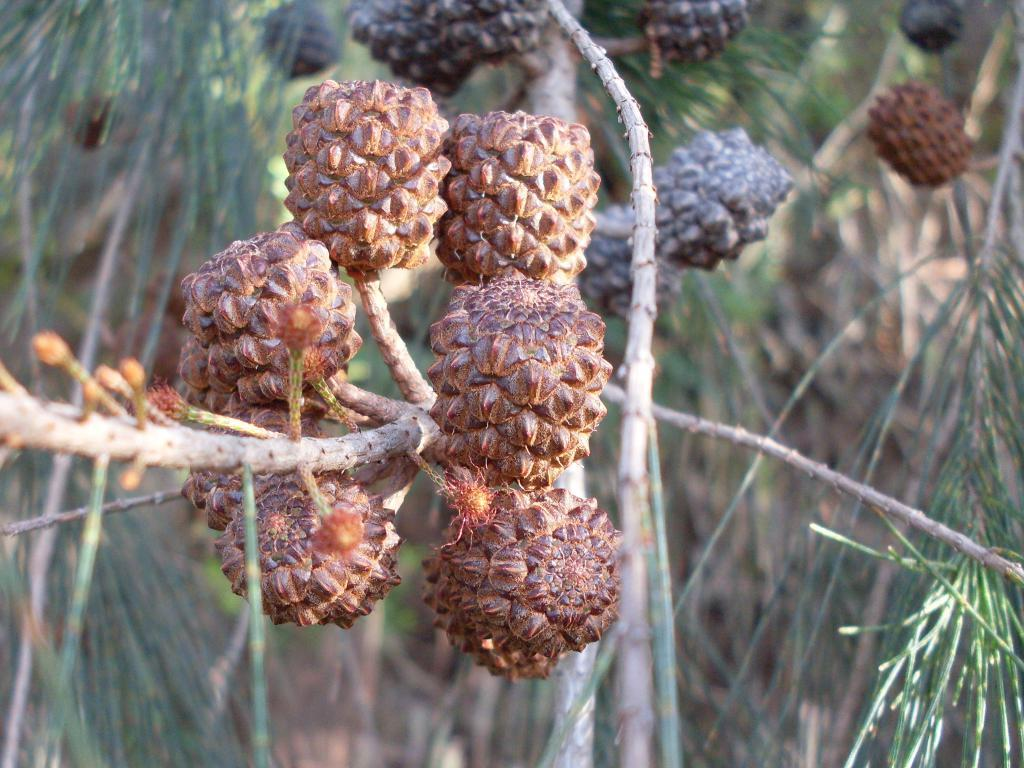What is the main object in the image? There is a tree in the image. What can be seen on the tree? There are fruits on the branches of the tree and leaves on the tree. How many people are in the crowd gathered around the tree in the image? There is no crowd present in the image; it only features a tree with fruits and leaves. Is there a kite flying above the tree in the image? There is no kite present in the image; it only features a tree with fruits and leaves. 